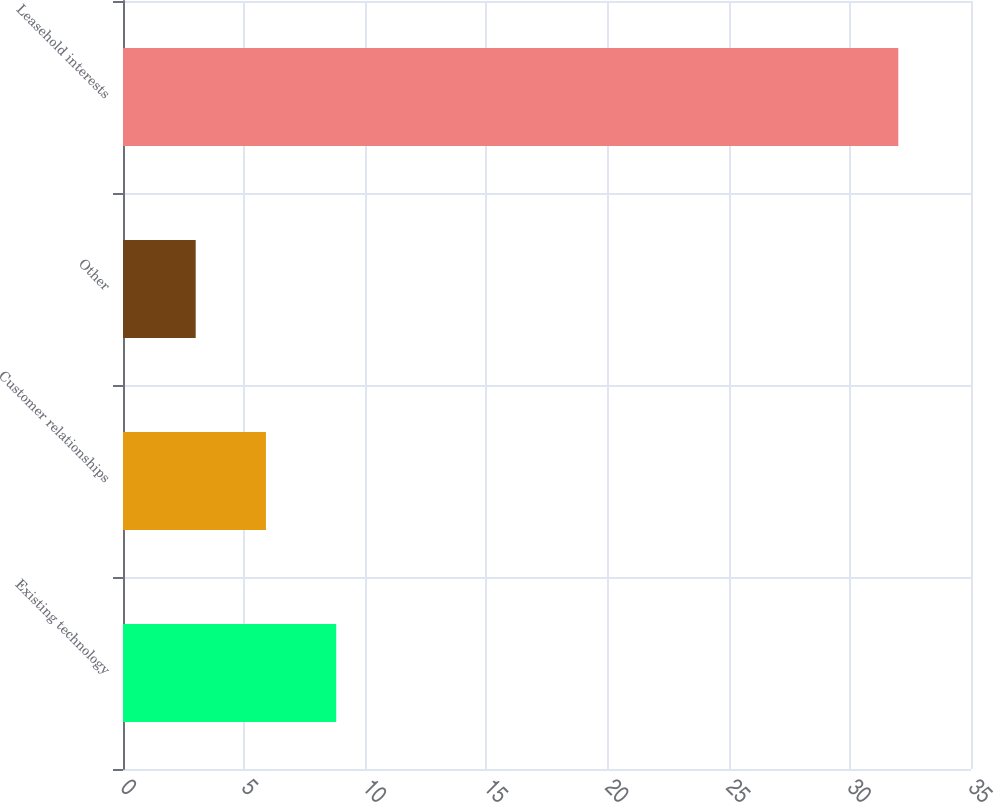Convert chart. <chart><loc_0><loc_0><loc_500><loc_500><bar_chart><fcel>Existing technology<fcel>Customer relationships<fcel>Other<fcel>Leasehold interests<nl><fcel>8.8<fcel>5.9<fcel>3<fcel>32<nl></chart> 